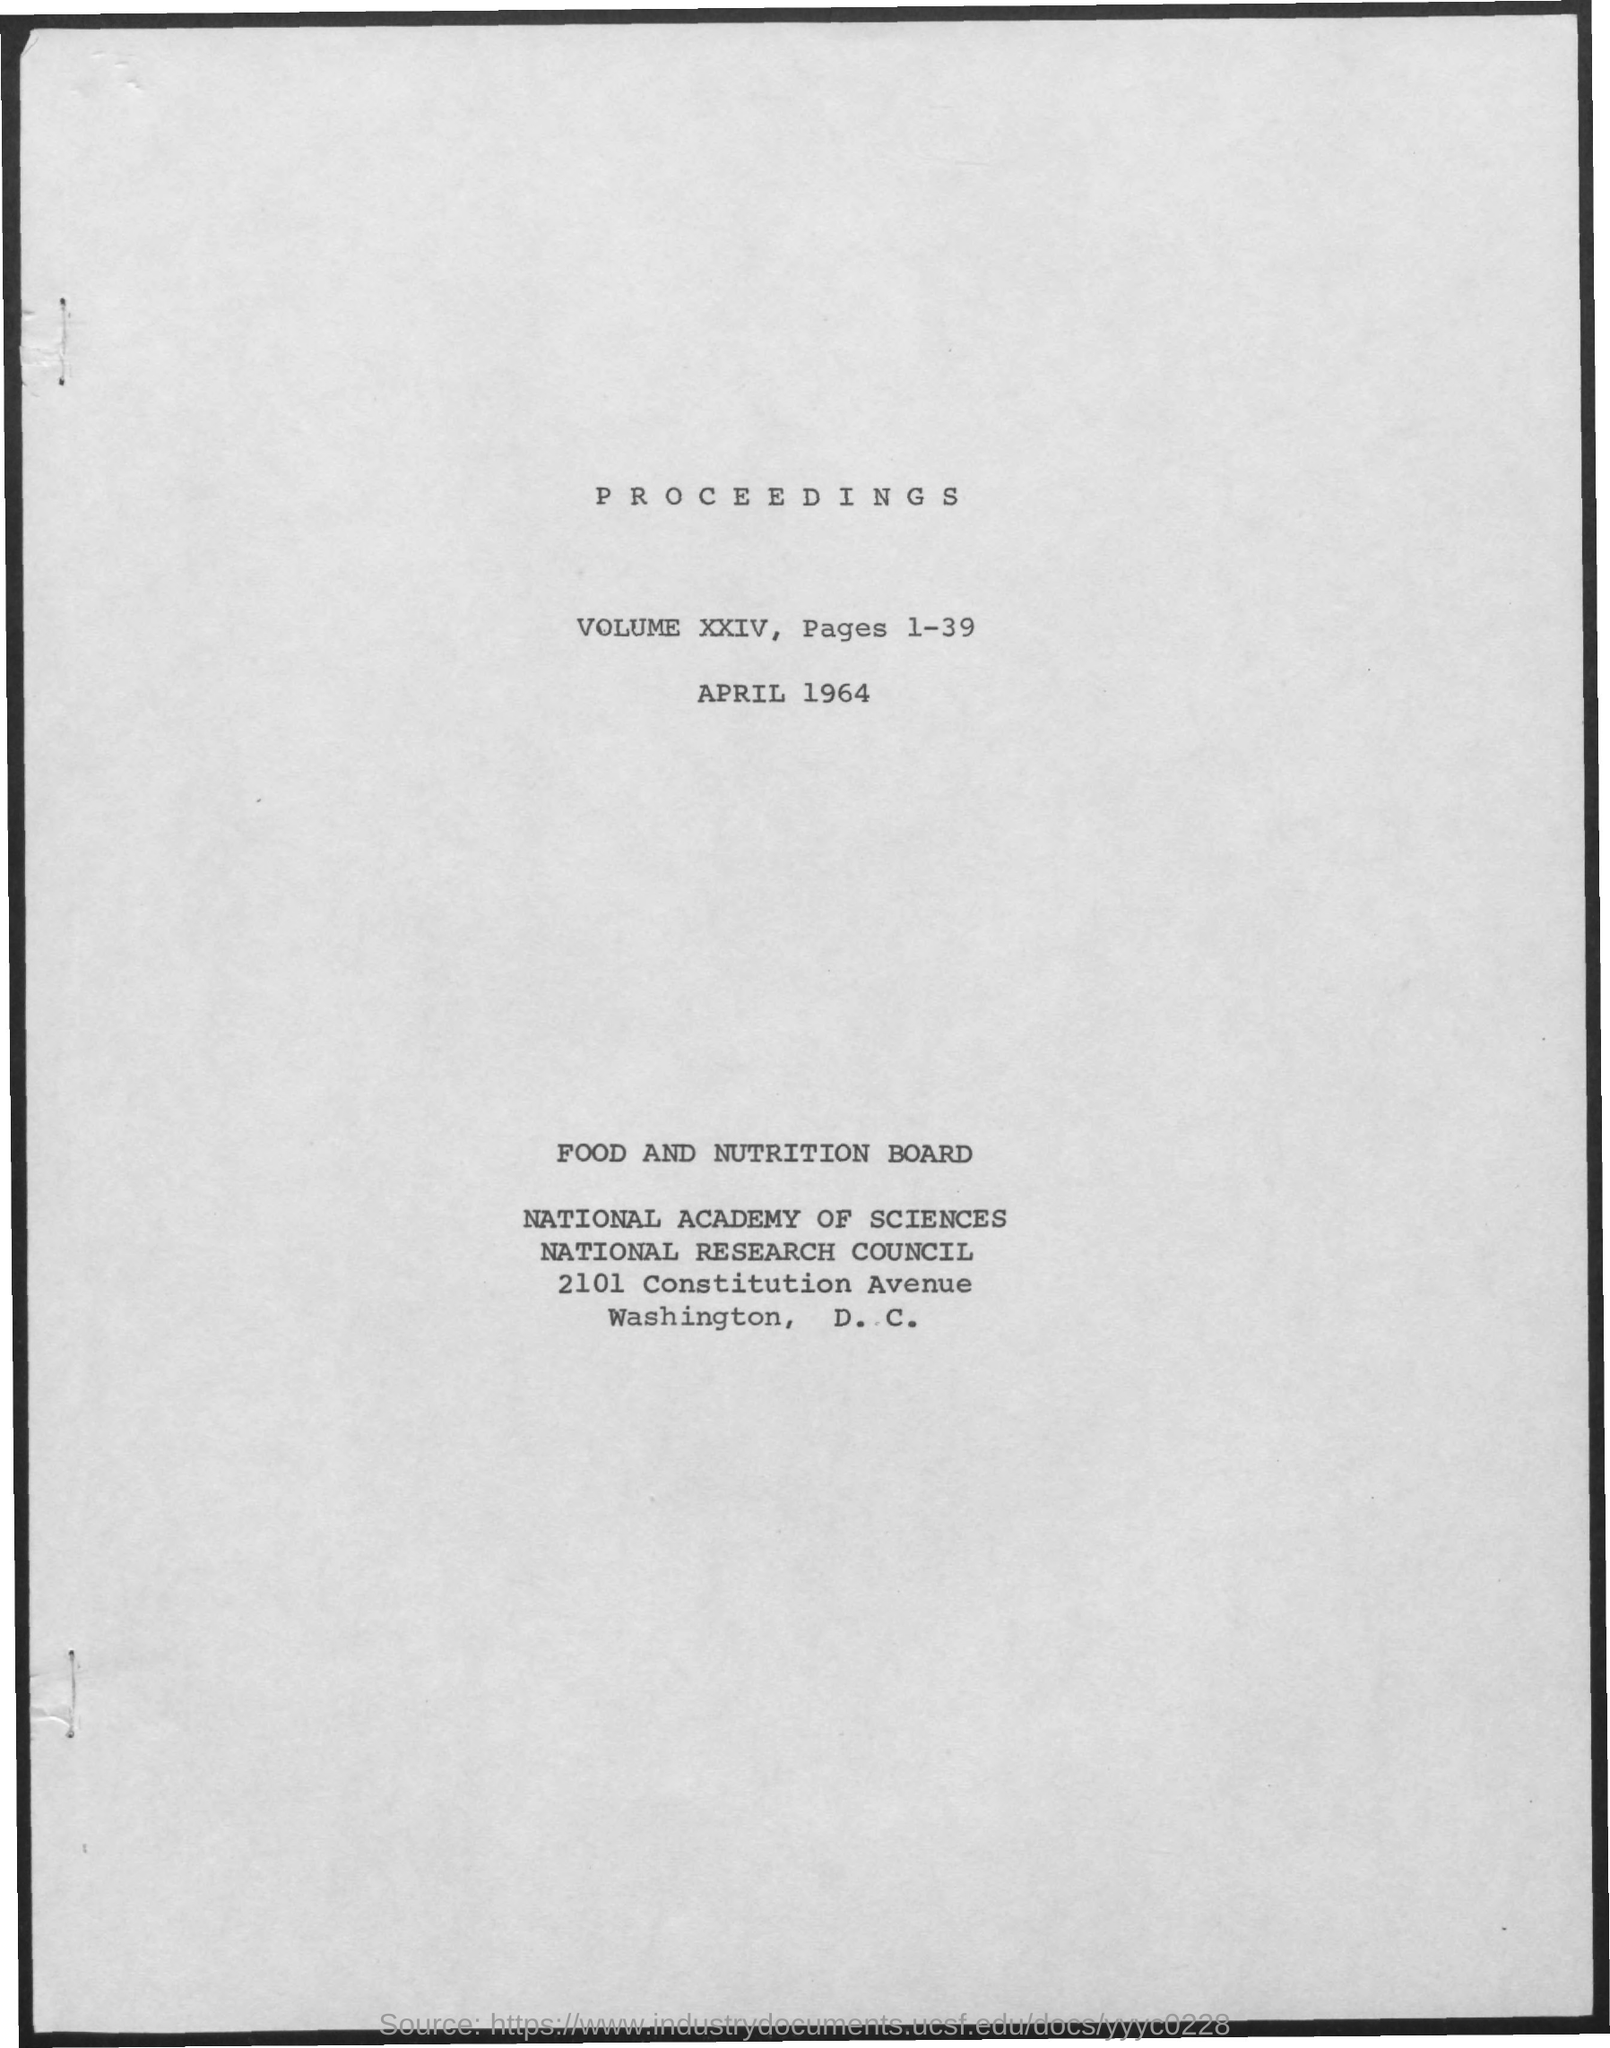What is the Volume?
Ensure brevity in your answer.  XXIV. What are the pages?
Make the answer very short. 1-39. What is the Date?
Provide a short and direct response. April 1964. What is the Title of the document?
Provide a succinct answer. Proceedings. 